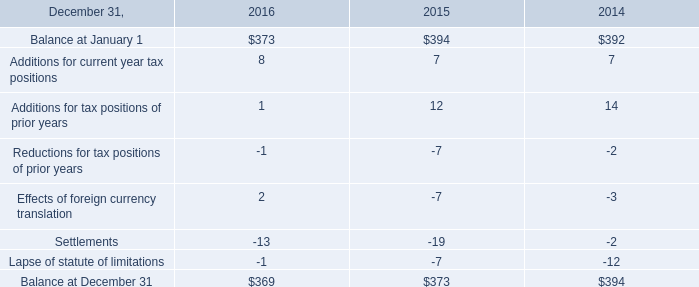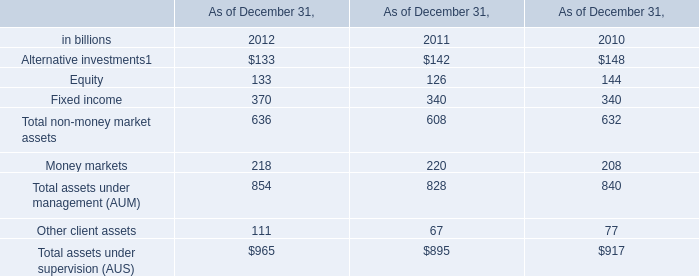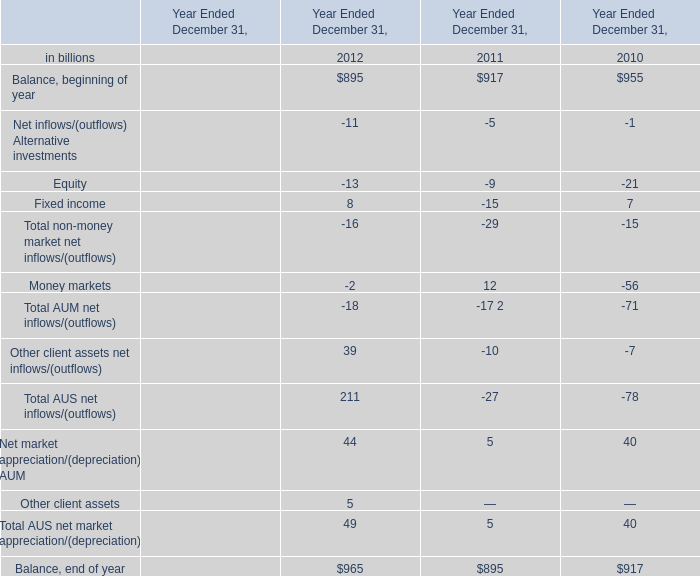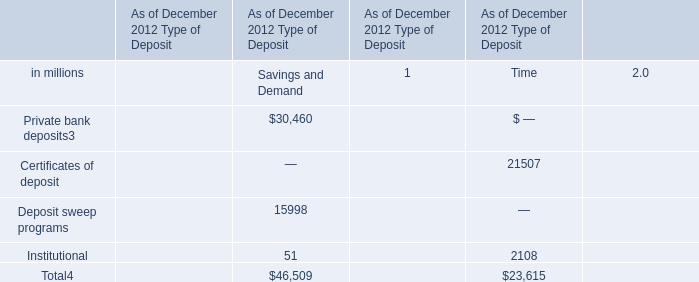What's the sum of all non-money market net inflows/(outflows) that are greater than -10 in 2011? (in billion) 
Computations: (-5 + -9)
Answer: -14.0. 